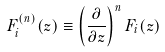Convert formula to latex. <formula><loc_0><loc_0><loc_500><loc_500>F _ { i } ^ { ( n ) } ( z ) \equiv \left ( \frac { \partial } { \partial z } \right ) ^ { n } F _ { i } ( z )</formula> 